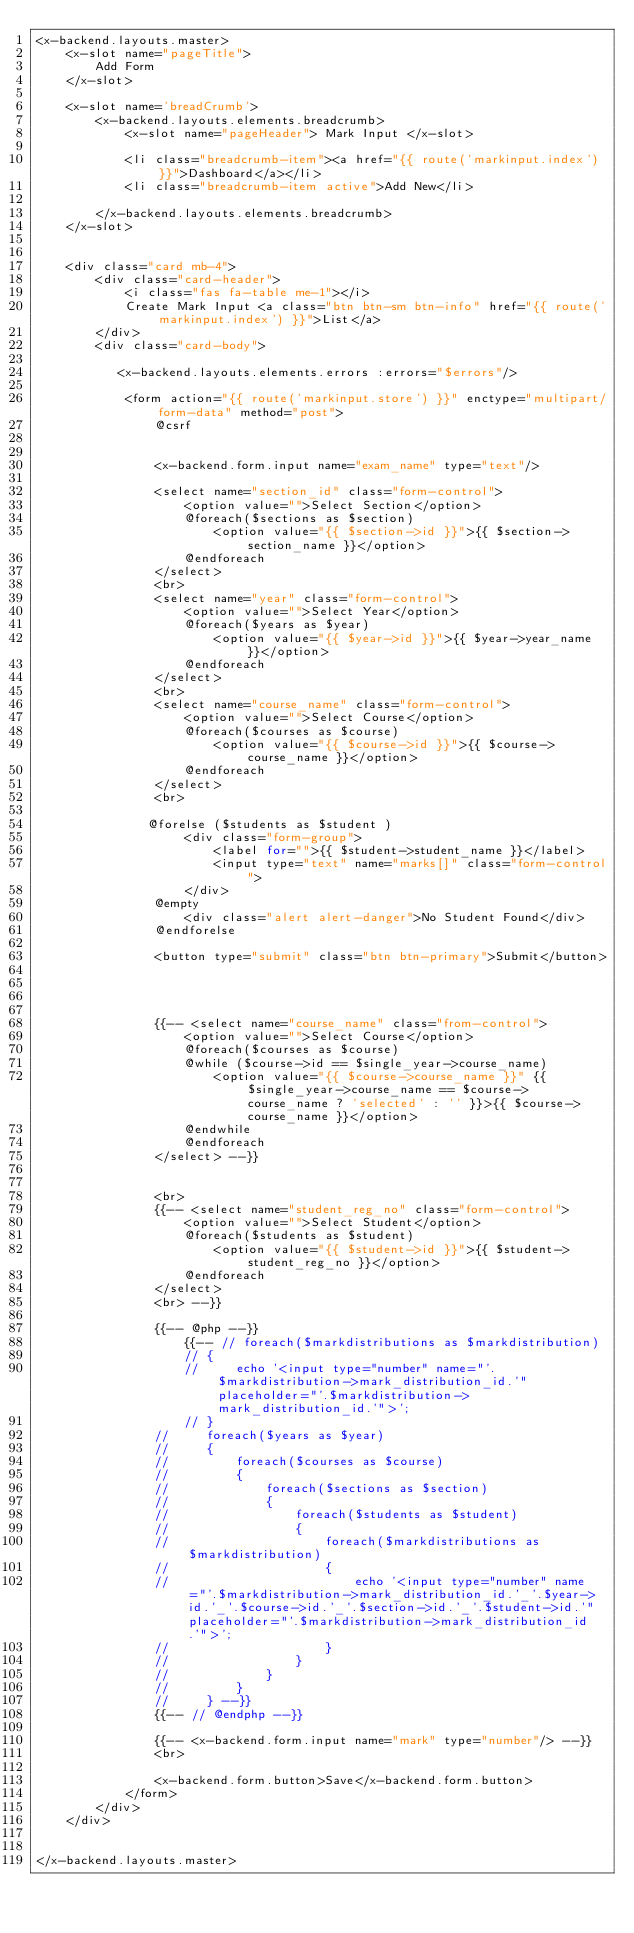Convert code to text. <code><loc_0><loc_0><loc_500><loc_500><_PHP_><x-backend.layouts.master>
    <x-slot name="pageTitle">
        Add Form
    </x-slot>

    <x-slot name='breadCrumb'>
        <x-backend.layouts.elements.breadcrumb>
            <x-slot name="pageHeader"> Mark Input </x-slot>

            <li class="breadcrumb-item"><a href="{{ route('markinput.index')}}">Dashboard</a></li>
            <li class="breadcrumb-item active">Add New</li>

        </x-backend.layouts.elements.breadcrumb>
    </x-slot>


    <div class="card mb-4">
        <div class="card-header">
            <i class="fas fa-table me-1"></i>
            Create Mark Input <a class="btn btn-sm btn-info" href="{{ route('markinput.index') }}">List</a>
        </div>
        <div class="card-body">

           <x-backend.layouts.elements.errors :errors="$errors"/>

            <form action="{{ route('markinput.store') }}" enctype="multipart/form-data" method="post">
                @csrf

               
                <x-backend.form.input name="exam_name" type="text"/>

                <select name="section_id" class="form-control">
                    <option value="">Select Section</option>
                    @foreach($sections as $section)
                        <option value="{{ $section->id }}">{{ $section->section_name }}</option>
                    @endforeach
                </select>
                <br>
                <select name="year" class="form-control">
                    <option value="">Select Year</option>
                    @foreach($years as $year)
                        <option value="{{ $year->id }}">{{ $year->year_name }}</option>
                    @endforeach
                </select>
                <br>
                <select name="course_name" class="form-control">
                    <option value="">Select Course</option>
                    @foreach($courses as $course)
                        <option value="{{ $course->id }}">{{ $course->course_name }}</option>
                    @endforeach
                </select>
                <br>

               @forelse ($students as $student )
                    <div class="form-group">
                        <label for="">{{ $student->student_name }}</label>
                        <input type="text" name="marks[]" class="form-control">
                    </div>
                @empty
                    <div class="alert alert-danger">No Student Found</div>
                @endforelse

                <button type="submit" class="btn btn-primary">Submit</button>




                {{-- <select name="course_name" class="from-control">
                    <option value="">Select Course</option>
                    @foreach($courses as $course)
                    @while ($course->id == $single_year->course_name)
                        <option value="{{ $course->course_name }}" {{ $single_year->course_name == $course->course_name ? 'selected' : '' }}>{{ $course->course_name }}</option>
                    @endwhile
                    @endforeach
                </select> --}}
                    
              
                <br>
                {{-- <select name="student_reg_no" class="form-control">
                    <option value="">Select Student</option>
                    @foreach($students as $student)
                        <option value="{{ $student->id }}">{{ $student->student_reg_no }}</option>
                    @endforeach
                </select>
                <br> --}}

                {{-- @php --}}
                    {{-- // foreach($markdistributions as $markdistribution)
                    // {
                    //     echo '<input type="number" name="'.$markdistribution->mark_distribution_id.'" placeholder="'.$markdistribution->mark_distribution_id.'">';
                    // }
                //     foreach($years as $year)
                //     {
                //         foreach($courses as $course)
                //         {
                //             foreach($sections as $section)
                //             {
                //                 foreach($students as $student)
                //                 {
                //                     foreach($markdistributions as $markdistribution)
                //                     {
                //                         echo '<input type="number" name="'.$markdistribution->mark_distribution_id.'_'.$year->id.'_'.$course->id.'_'.$section->id.'_'.$student->id.'" placeholder="'.$markdistribution->mark_distribution_id.'">';
                //                     }
                //                 }
                //             }
                //         }
                //     } --}}
                {{-- // @endphp --}}

                {{-- <x-backend.form.input name="mark" type="number"/> --}}
                <br>

                <x-backend.form.button>Save</x-backend.form.button>
            </form>
        </div>
    </div>


</x-backend.layouts.master></code> 